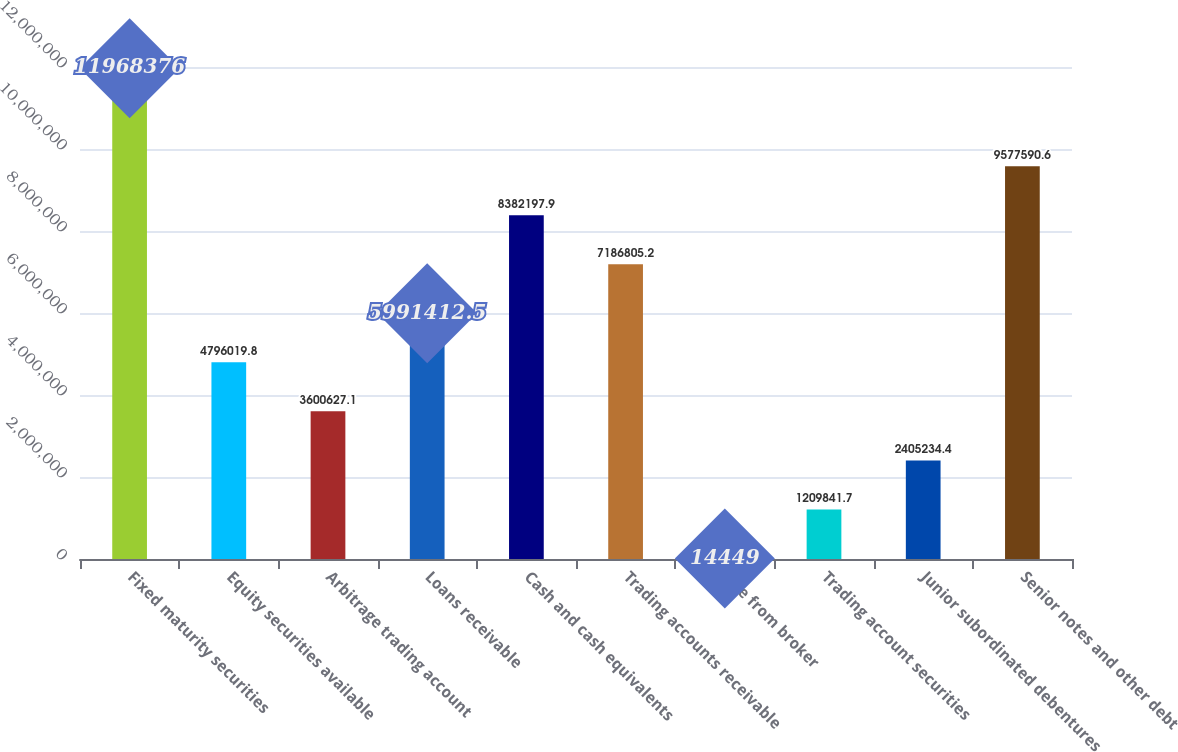Convert chart to OTSL. <chart><loc_0><loc_0><loc_500><loc_500><bar_chart><fcel>Fixed maturity securities<fcel>Equity securities available<fcel>Arbitrage trading account<fcel>Loans receivable<fcel>Cash and cash equivalents<fcel>Trading accounts receivable<fcel>Due from broker<fcel>Trading account securities<fcel>Junior subordinated debentures<fcel>Senior notes and other debt<nl><fcel>1.19684e+07<fcel>4.79602e+06<fcel>3.60063e+06<fcel>5.99141e+06<fcel>8.3822e+06<fcel>7.18681e+06<fcel>14449<fcel>1.20984e+06<fcel>2.40523e+06<fcel>9.57759e+06<nl></chart> 